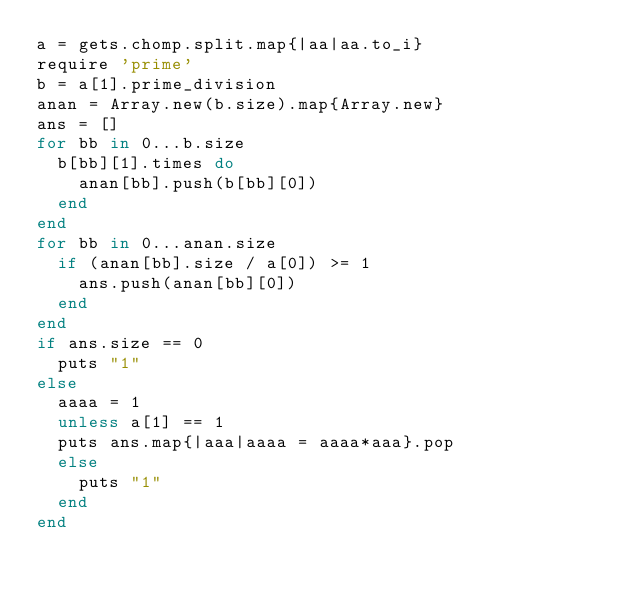<code> <loc_0><loc_0><loc_500><loc_500><_Ruby_>a = gets.chomp.split.map{|aa|aa.to_i}
require 'prime'
b = a[1].prime_division
anan = Array.new(b.size).map{Array.new}
ans = []
for bb in 0...b.size
  b[bb][1].times do
    anan[bb].push(b[bb][0])
  end
end
for bb in 0...anan.size
  if (anan[bb].size / a[0]) >= 1
    ans.push(anan[bb][0])
  end
end
if ans.size == 0
  puts "1"
else
  aaaa = 1
  unless a[1] == 1
  puts ans.map{|aaa|aaaa = aaaa*aaa}.pop
  else
    puts "1"
  end
end
</code> 